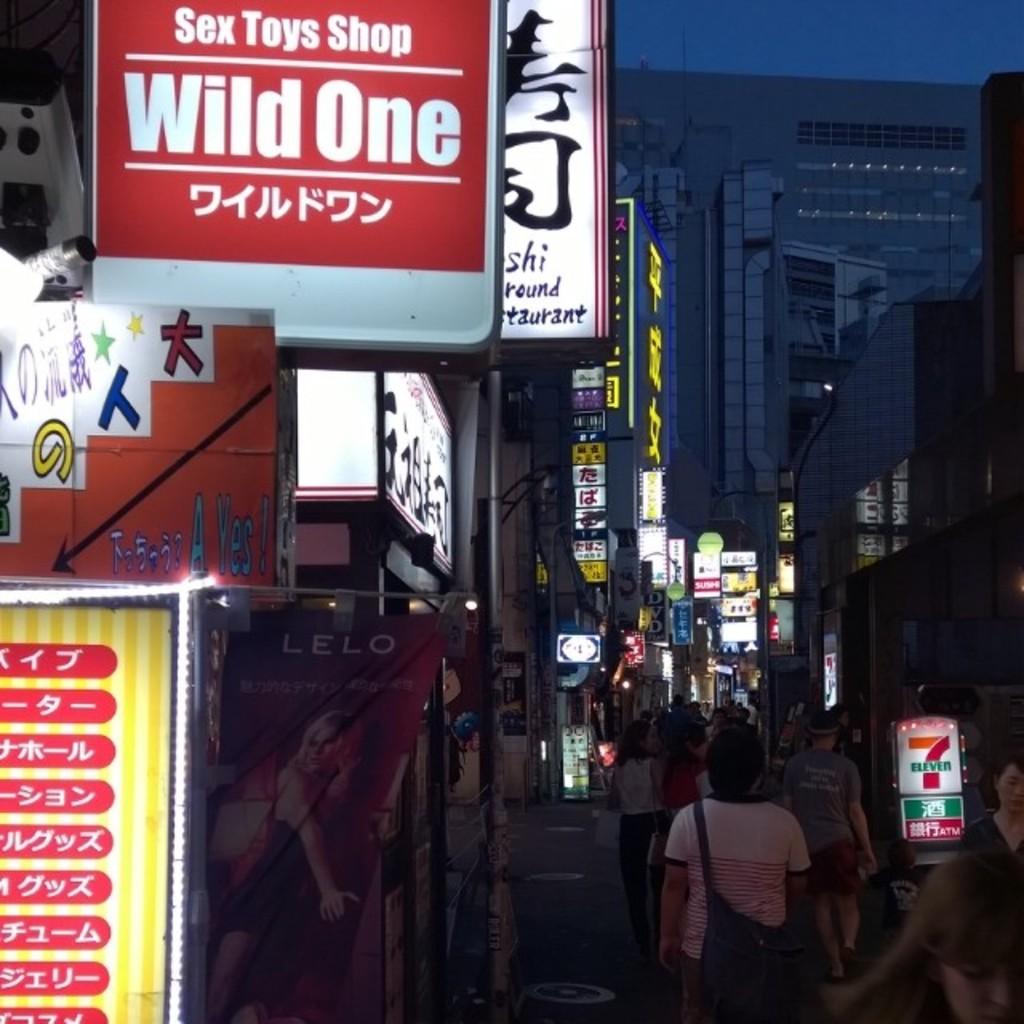What store is that?
Provide a succinct answer. Wild one. 